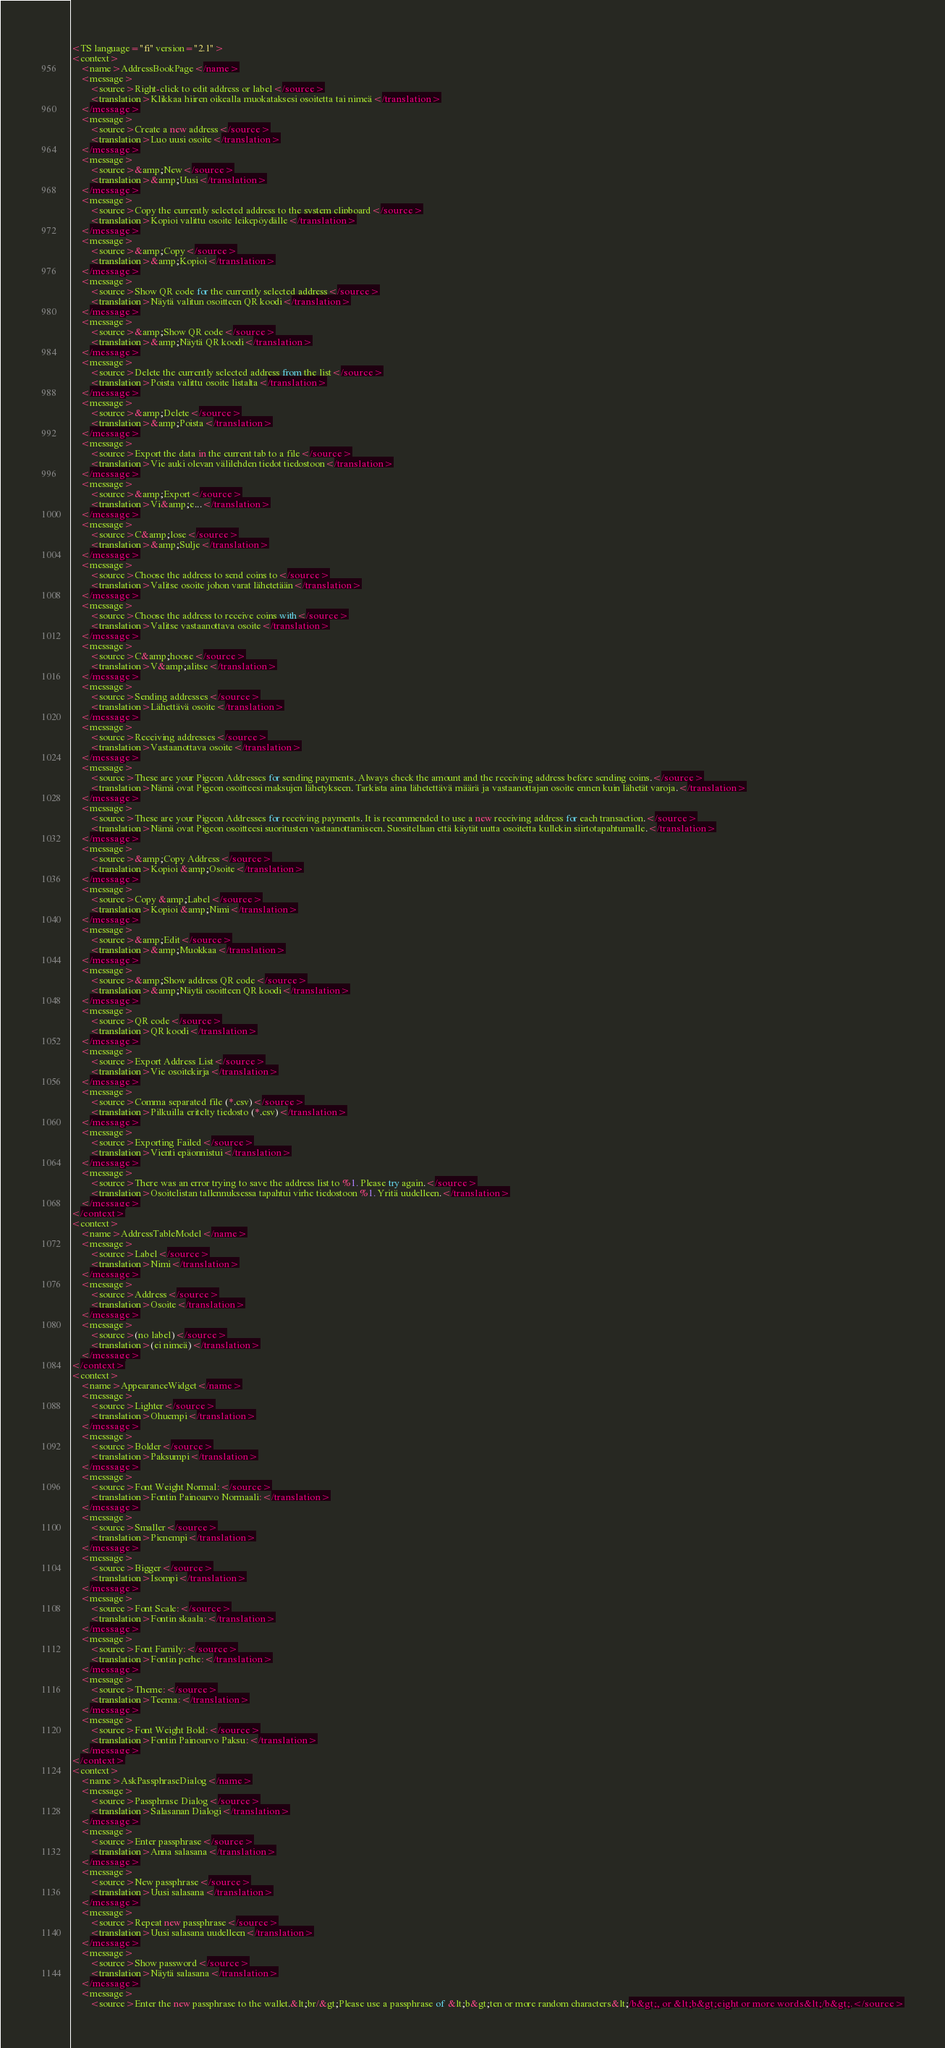<code> <loc_0><loc_0><loc_500><loc_500><_TypeScript_><TS language="fi" version="2.1">
<context>
    <name>AddressBookPage</name>
    <message>
        <source>Right-click to edit address or label</source>
        <translation>Klikkaa hiiren oikealla muokataksesi osoitetta tai nimeä</translation>
    </message>
    <message>
        <source>Create a new address</source>
        <translation>Luo uusi osoite</translation>
    </message>
    <message>
        <source>&amp;New</source>
        <translation>&amp;Uusi</translation>
    </message>
    <message>
        <source>Copy the currently selected address to the system clipboard</source>
        <translation>Kopioi valittu osoite leikepöydälle</translation>
    </message>
    <message>
        <source>&amp;Copy</source>
        <translation>&amp;Kopioi</translation>
    </message>
    <message>
        <source>Show QR code for the currently selected address</source>
        <translation>Näytä valitun osoitteen QR koodi</translation>
    </message>
    <message>
        <source>&amp;Show QR code</source>
        <translation>&amp;Näytä QR koodi</translation>
    </message>
    <message>
        <source>Delete the currently selected address from the list</source>
        <translation>Poista valittu osoite listalta</translation>
    </message>
    <message>
        <source>&amp;Delete</source>
        <translation>&amp;Poista</translation>
    </message>
    <message>
        <source>Export the data in the current tab to a file</source>
        <translation>Vie auki olevan välilehden tiedot tiedostoon</translation>
    </message>
    <message>
        <source>&amp;Export</source>
        <translation>Vi&amp;e...</translation>
    </message>
    <message>
        <source>C&amp;lose</source>
        <translation>&amp;Sulje</translation>
    </message>
    <message>
        <source>Choose the address to send coins to</source>
        <translation>Valitse osoite johon varat lähetetään</translation>
    </message>
    <message>
        <source>Choose the address to receive coins with</source>
        <translation>Valitse vastaanottava osoite</translation>
    </message>
    <message>
        <source>C&amp;hoose</source>
        <translation>V&amp;alitse</translation>
    </message>
    <message>
        <source>Sending addresses</source>
        <translation>Lähettävä osoite</translation>
    </message>
    <message>
        <source>Receiving addresses</source>
        <translation>Vastaanottava osoite</translation>
    </message>
    <message>
        <source>These are your Pigeon Addresses for sending payments. Always check the amount and the receiving address before sending coins.</source>
        <translation>Nämä ovat Pigeon osoitteesi maksujen lähetykseen. Tarkista aina lähetettävä määrä ja vastaanottajan osoite ennen kuin lähetät varoja.</translation>
    </message>
    <message>
        <source>These are your Pigeon Addresses for receiving payments. It is recommended to use a new receiving address for each transaction.</source>
        <translation>Nämä ovat Pigeon osoitteesi suoritusten vastaanottamiseen. Suositellaan että käytät uutta osoitetta kullekin siirtotapahtumalle.</translation>
    </message>
    <message>
        <source>&amp;Copy Address</source>
        <translation>Kopioi &amp;Osoite</translation>
    </message>
    <message>
        <source>Copy &amp;Label</source>
        <translation>Kopioi &amp;Nimi</translation>
    </message>
    <message>
        <source>&amp;Edit</source>
        <translation>&amp;Muokkaa</translation>
    </message>
    <message>
        <source>&amp;Show address QR code</source>
        <translation>&amp;Näytä osoitteen QR koodi</translation>
    </message>
    <message>
        <source>QR code</source>
        <translation>QR koodi</translation>
    </message>
    <message>
        <source>Export Address List</source>
        <translation>Vie osoitekirja</translation>
    </message>
    <message>
        <source>Comma separated file (*.csv)</source>
        <translation>Pilkuilla eritelty tiedosto (*.csv)</translation>
    </message>
    <message>
        <source>Exporting Failed</source>
        <translation>Vienti epäonnistui</translation>
    </message>
    <message>
        <source>There was an error trying to save the address list to %1. Please try again.</source>
        <translation>Osoitelistan tallennuksessa tapahtui virhe tiedostoon %1. Yritä uudelleen.</translation>
    </message>
</context>
<context>
    <name>AddressTableModel</name>
    <message>
        <source>Label</source>
        <translation>Nimi</translation>
    </message>
    <message>
        <source>Address</source>
        <translation>Osoite</translation>
    </message>
    <message>
        <source>(no label)</source>
        <translation>(ei nimeä)</translation>
    </message>
</context>
<context>
    <name>AppearanceWidget</name>
    <message>
        <source>Lighter</source>
        <translation>Ohuempi</translation>
    </message>
    <message>
        <source>Bolder</source>
        <translation>Paksumpi</translation>
    </message>
    <message>
        <source>Font Weight Normal:</source>
        <translation>Fontin Painoarvo Normaali:</translation>
    </message>
    <message>
        <source>Smaller</source>
        <translation>Pienempi</translation>
    </message>
    <message>
        <source>Bigger</source>
        <translation>Isompi</translation>
    </message>
    <message>
        <source>Font Scale:</source>
        <translation>Fontin skaala:</translation>
    </message>
    <message>
        <source>Font Family:</source>
        <translation>Fontin perhe:</translation>
    </message>
    <message>
        <source>Theme:</source>
        <translation>Teema:</translation>
    </message>
    <message>
        <source>Font Weight Bold:</source>
        <translation>Fontin Painoarvo Paksu:</translation>
    </message>
</context>
<context>
    <name>AskPassphraseDialog</name>
    <message>
        <source>Passphrase Dialog</source>
        <translation>Salasanan Dialogi</translation>
    </message>
    <message>
        <source>Enter passphrase</source>
        <translation>Anna salasana</translation>
    </message>
    <message>
        <source>New passphrase</source>
        <translation>Uusi salasana</translation>
    </message>
    <message>
        <source>Repeat new passphrase</source>
        <translation>Uusi salasana uudelleen</translation>
    </message>
    <message>
        <source>Show password</source>
        <translation>Näytä salasana</translation>
    </message>
    <message>
        <source>Enter the new passphrase to the wallet.&lt;br/&gt;Please use a passphrase of &lt;b&gt;ten or more random characters&lt;/b&gt;, or &lt;b&gt;eight or more words&lt;/b&gt;.</source></code> 